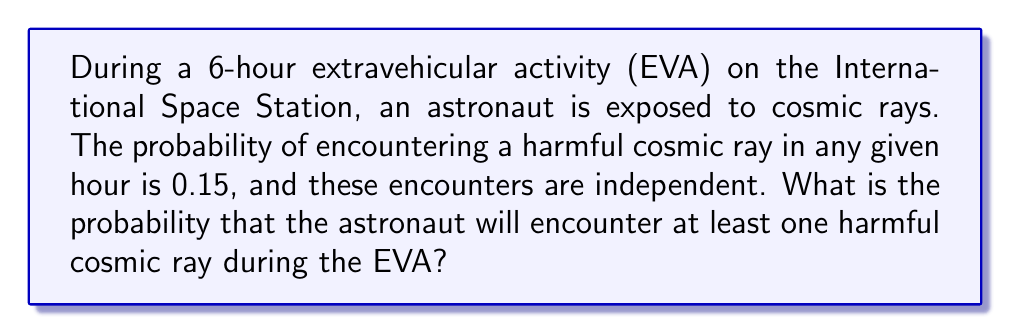Solve this math problem. Let's approach this step-by-step:

1) First, we need to calculate the probability of not encountering any harmful cosmic rays during one hour:
   $P(\text{no harmful ray in 1 hour}) = 1 - 0.15 = 0.85$

2) Since the EVA lasts for 6 hours and the encounters are independent, we can use the multiplication rule of probability. The probability of not encountering any harmful cosmic rays during the entire 6-hour EVA is:
   $P(\text{no harmful rays in 6 hours}) = 0.85^6$

3) Now, we can calculate this:
   $0.85^6 \approx 0.3771$

4) The question asks for the probability of encountering at least one harmful cosmic ray. This is the complement of the probability of encountering no harmful cosmic rays:
   $P(\text{at least one harmful ray}) = 1 - P(\text{no harmful rays in 6 hours})$

5) Therefore:
   $P(\text{at least one harmful ray}) = 1 - 0.3771 \approx 0.6229$

6) Converting to a percentage:
   $0.6229 \times 100\% \approx 62.29\%$
Answer: $62.29\%$ 